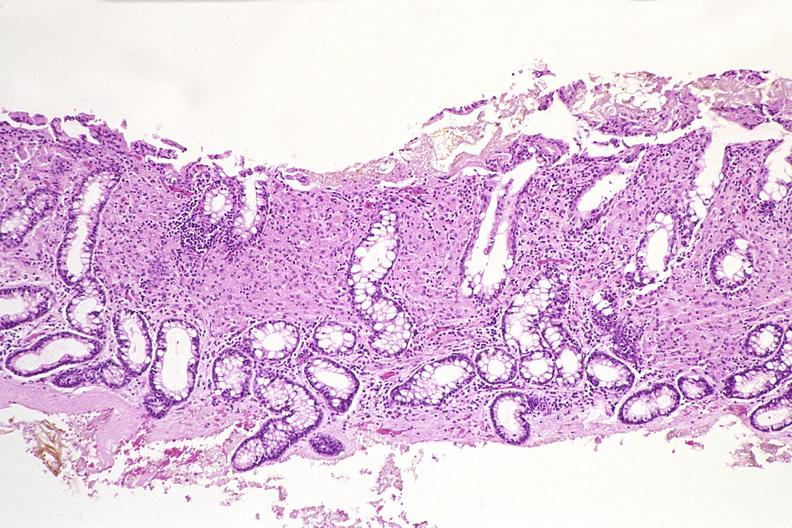what does this image show?
Answer the question using a single word or phrase. Colon biopsy 